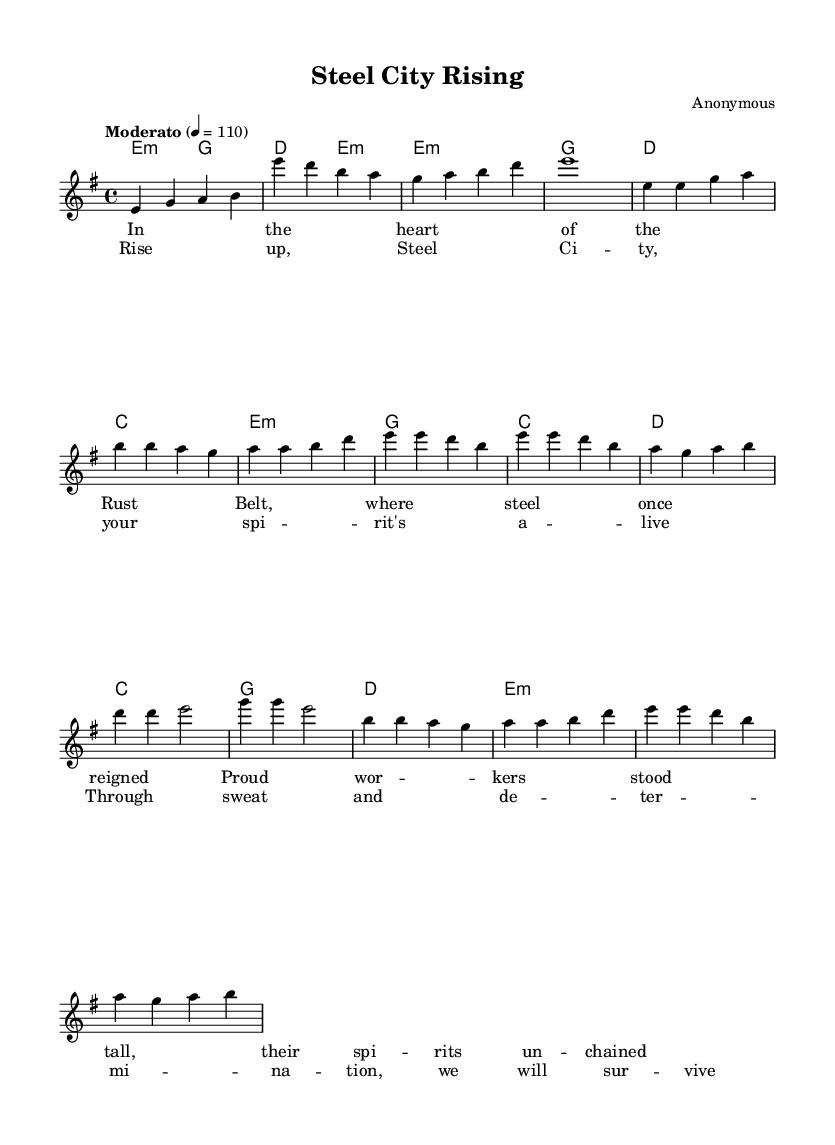What is the key signature of this music? The key signature is indicated by the presence of one sharp (F#), which means it is E minor.
Answer: E minor What is the time signature of this music? The time signature is shown as a fraction at the beginning of the piece; it is 4/4.
Answer: 4/4 What is the tempo marking for the piece? The tempo marking is written in Italian, indicating a moderate pace; it states "Moderato" at the beginning.
Answer: Moderato How many measures are in the chorus section? By counting the measures in the section marked as the chorus, you find a total of four measures.
Answer: 4 What is the first note of the melody? The first note appears in the melody right after the tempo marking, which is an E note.
Answer: E In which section do the lyrics mention “steel”? The word “steel” appears in the verse section of the lyrics, specifically noting where the context of the location is discussed.
Answer: Verse Which chord is used in the first measure? The first chord in the chord progression is identified as E minor, which is specified at the beginning of the music.
Answer: E minor 